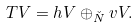Convert formula to latex. <formula><loc_0><loc_0><loc_500><loc_500>T V = h V \oplus _ { \check { N } } v V .</formula> 